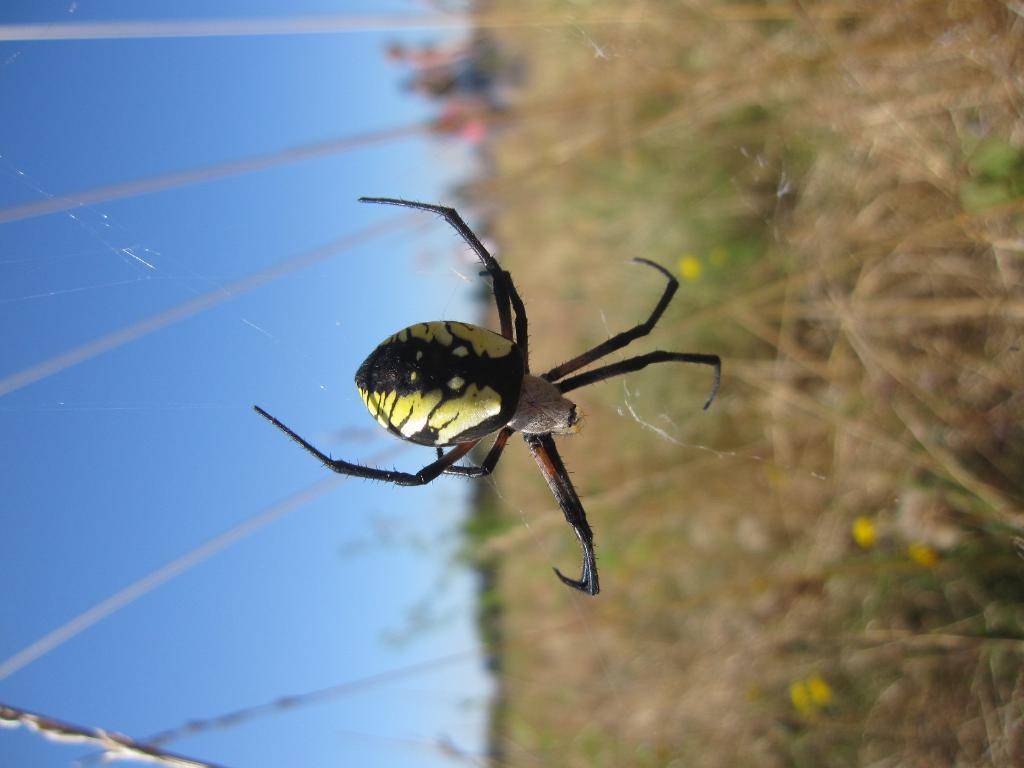How would you summarize this image in a sentence or two? In this picture we can see the sky and an insect. Right side of the picture is blurry and we can see the plants. 